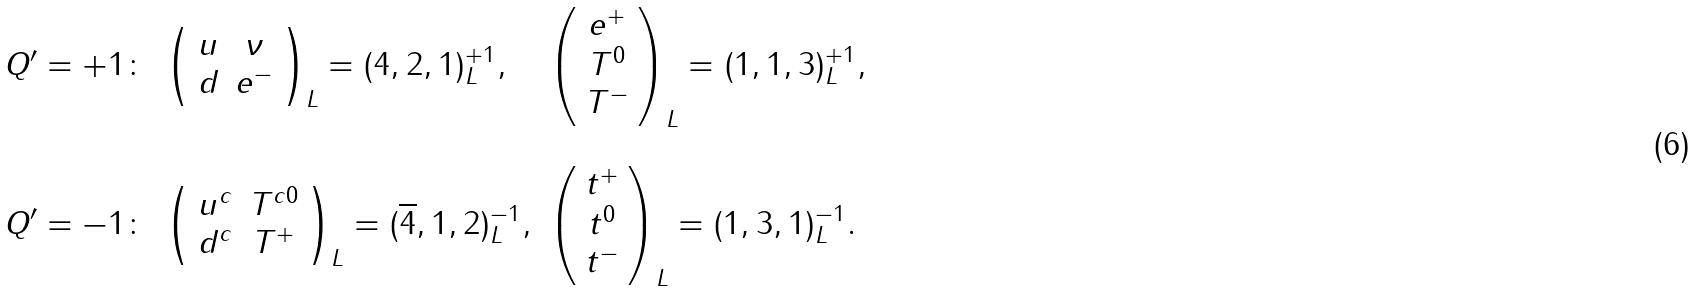<formula> <loc_0><loc_0><loc_500><loc_500>\begin{array} { c l l } Q ^ { \prime } = + 1 \colon & \left ( \begin{array} { c c } u & \nu \\ d & e ^ { - } \end{array} \right ) _ { L } = ( 4 , 2 , 1 ) ^ { + 1 } _ { L } , & \left ( \begin{array} { c } e ^ { + } \\ T ^ { 0 } \\ T ^ { - } \end{array} \right ) _ { L } = ( 1 , 1 , 3 ) ^ { + 1 } _ { L } , \\ & & \\ Q ^ { \prime } = - 1 \colon & \left ( \begin{array} { c c } u ^ { c } & T ^ { c 0 } \\ d ^ { c } & T ^ { + } \end{array} \right ) _ { L } = ( \overline { 4 } , 1 , 2 ) ^ { - 1 } _ { L } , & \left ( \begin{array} { c } t ^ { + } \\ t ^ { 0 } \\ t ^ { - } \end{array} \right ) _ { L } = ( 1 , 3 , 1 ) ^ { - 1 } _ { L } . \end{array}</formula> 